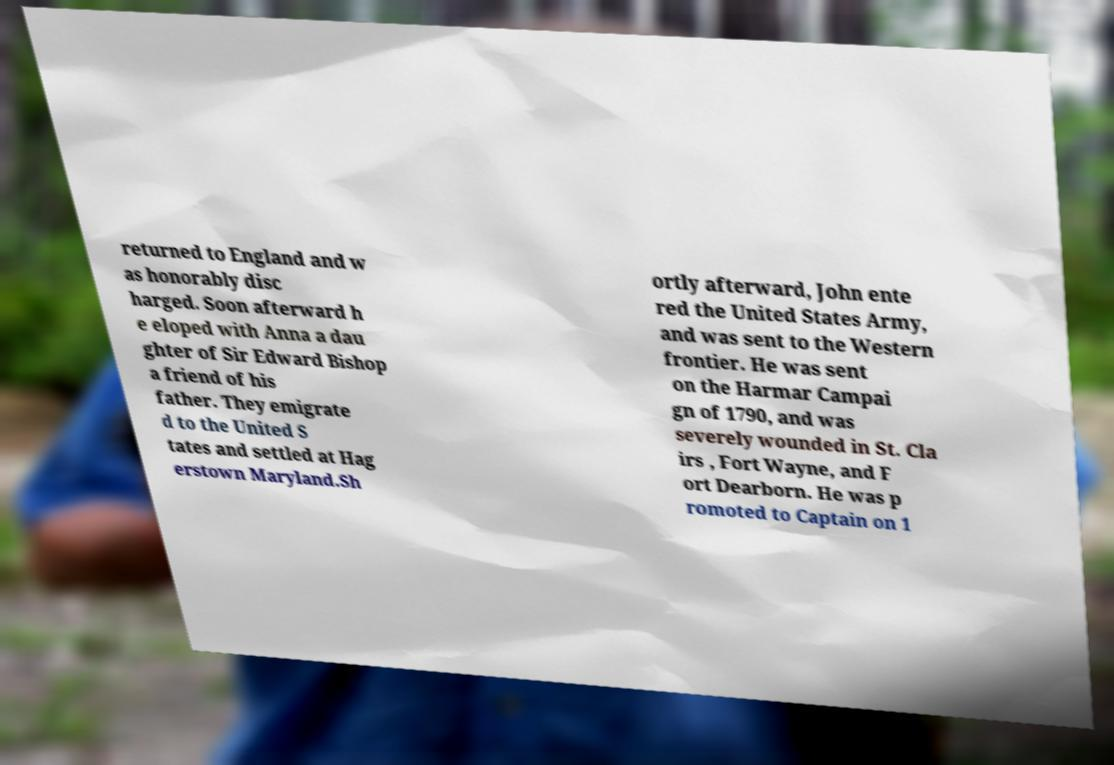I need the written content from this picture converted into text. Can you do that? returned to England and w as honorably disc harged. Soon afterward h e eloped with Anna a dau ghter of Sir Edward Bishop a friend of his father. They emigrate d to the United S tates and settled at Hag erstown Maryland.Sh ortly afterward, John ente red the United States Army, and was sent to the Western frontier. He was sent on the Harmar Campai gn of 1790, and was severely wounded in St. Cla irs , Fort Wayne, and F ort Dearborn. He was p romoted to Captain on 1 